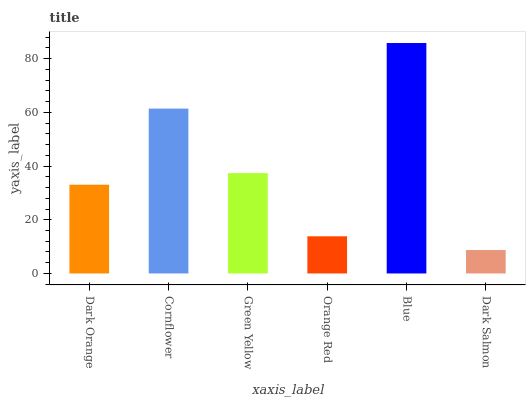Is Dark Salmon the minimum?
Answer yes or no. Yes. Is Blue the maximum?
Answer yes or no. Yes. Is Cornflower the minimum?
Answer yes or no. No. Is Cornflower the maximum?
Answer yes or no. No. Is Cornflower greater than Dark Orange?
Answer yes or no. Yes. Is Dark Orange less than Cornflower?
Answer yes or no. Yes. Is Dark Orange greater than Cornflower?
Answer yes or no. No. Is Cornflower less than Dark Orange?
Answer yes or no. No. Is Green Yellow the high median?
Answer yes or no. Yes. Is Dark Orange the low median?
Answer yes or no. Yes. Is Orange Red the high median?
Answer yes or no. No. Is Cornflower the low median?
Answer yes or no. No. 